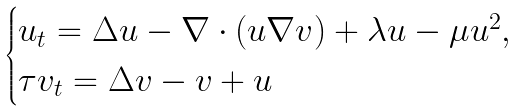<formula> <loc_0><loc_0><loc_500><loc_500>\begin{cases} u _ { t } = \Delta u - \nabla \cdot ( u \nabla v ) + \lambda u - \mu u ^ { 2 } , \\ \tau v _ { t } = \Delta v - v + u \end{cases}</formula> 